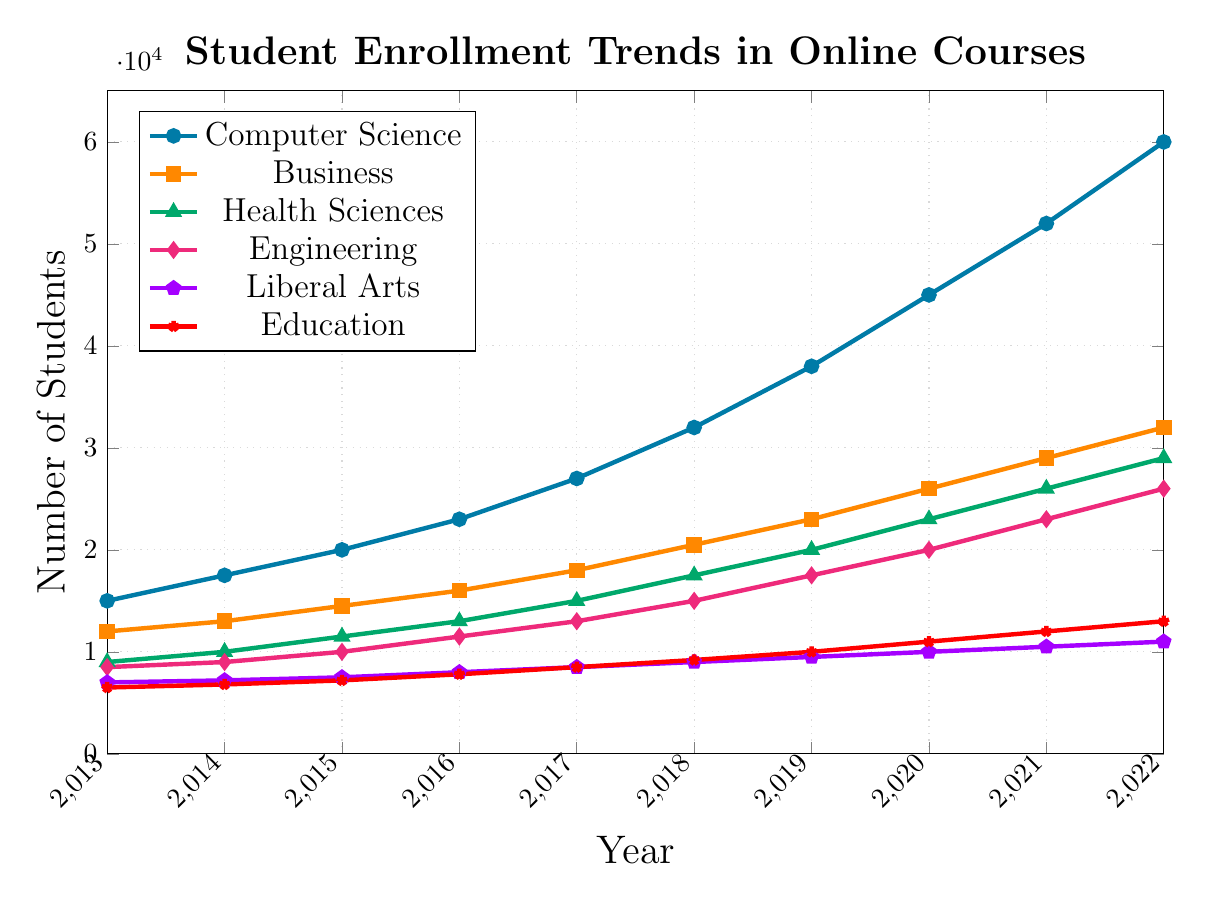Which subject had the highest student enrollment in 2022? From the chart, the subject with the highest number of students in 2022 is the one with the tallest line marker at 2022.
Answer: Computer Science Which subject area saw the largest absolute increase in student enrollment from 2013 to 2022? To find the subject with the largest absolute increase, subtract the 2013 value from the 2022 value for each subject. Compare these differences:
- Computer Science: 60000 - 15000 = 45000
- Business: 32000 - 12000 = 20000
- Health Sciences: 29000 - 9000 = 20000
- Engineering: 26000 - 8500 = 17500
- Liberal Arts: 11000 - 7000 = 4000
- Education: 13000 - 6500 = 6500
Computer Science has the largest increase.
Answer: Computer Science What is the average enrollment for Business courses over the decade? To find the average enrollment for Business courses, sum the enrollment numbers from 2013 to 2022 and divide by the number of years: (12000 + 13000 + 14500 + 16000 + 18000 + 20500 + 23000 + 26000 + 29000 + 32000) / 10 = 20400.
Answer: 20400 By how many students did enrollment in Health Sciences increase between 2017 and 2020? Subtract the 2017 value from the 2020 value for Health Sciences: 23000 - 15000 = 8000.
Answer: 8000 Which subject showed the most consistent growth over the decade? The subject with the most consistent growth would have a steady and proportional increase across the years. By observing the slopes of the lines, Computer Science appears to show a consistent upward trend without significant fluctuations, indicating steady growth.
Answer: Computer Science Between which consecutive years did Education see the highest increase in student enrollment? To determine this, calculate the year-on-year difference for Education and find the largest:
- 2013-2014: 6800 - 6500 = 300
- 2014-2015: 7200 - 6800 = 400
- 2015-2016: 7800 - 7200 = 600
- 2016-2017: 8500 - 7800 = 700
- 2017-2018: 9200 - 8500 = 700
- 2018-2019: 10000 - 9200 = 800
- 2019-2020: 11000 - 10000 = 1000
- 2020-2021: 12000 - 11000 = 1000
- 2021-2022: 13000 - 12000 = 1000
The highest increase is from 2019 to 2020, 2020 to 2021, and 2021 to 2022, with an increase of 1000 students.
Answer: 2019-2020, 2020-2021, 2021-2022 In which year did Business courses surpass 20,000 students in enrollment? Looking at the Business line, it crosses the 20,000 mark between 2017 and 2018.
Answer: 2018 Compare the total enrollment in Liberal Arts and Education in 2022. Which one had higher numbers? By directly comparing the 2022 values for both subjects: Liberal Arts: 11000, Education: 13000. Education had higher numbers.
Answer: Education How did the enrollment growth in Engineering compare to Health Sciences from 2013 to 2022? Calculate the absolute growth for both subjects between 2013 and 2022:
- Engineering: 26000 - 8500 = 17500
- Health Sciences: 29000 - 9000 = 20000
Health Sciences had a greater increase in student enrollment than Engineering.
Answer: Health Sciences 